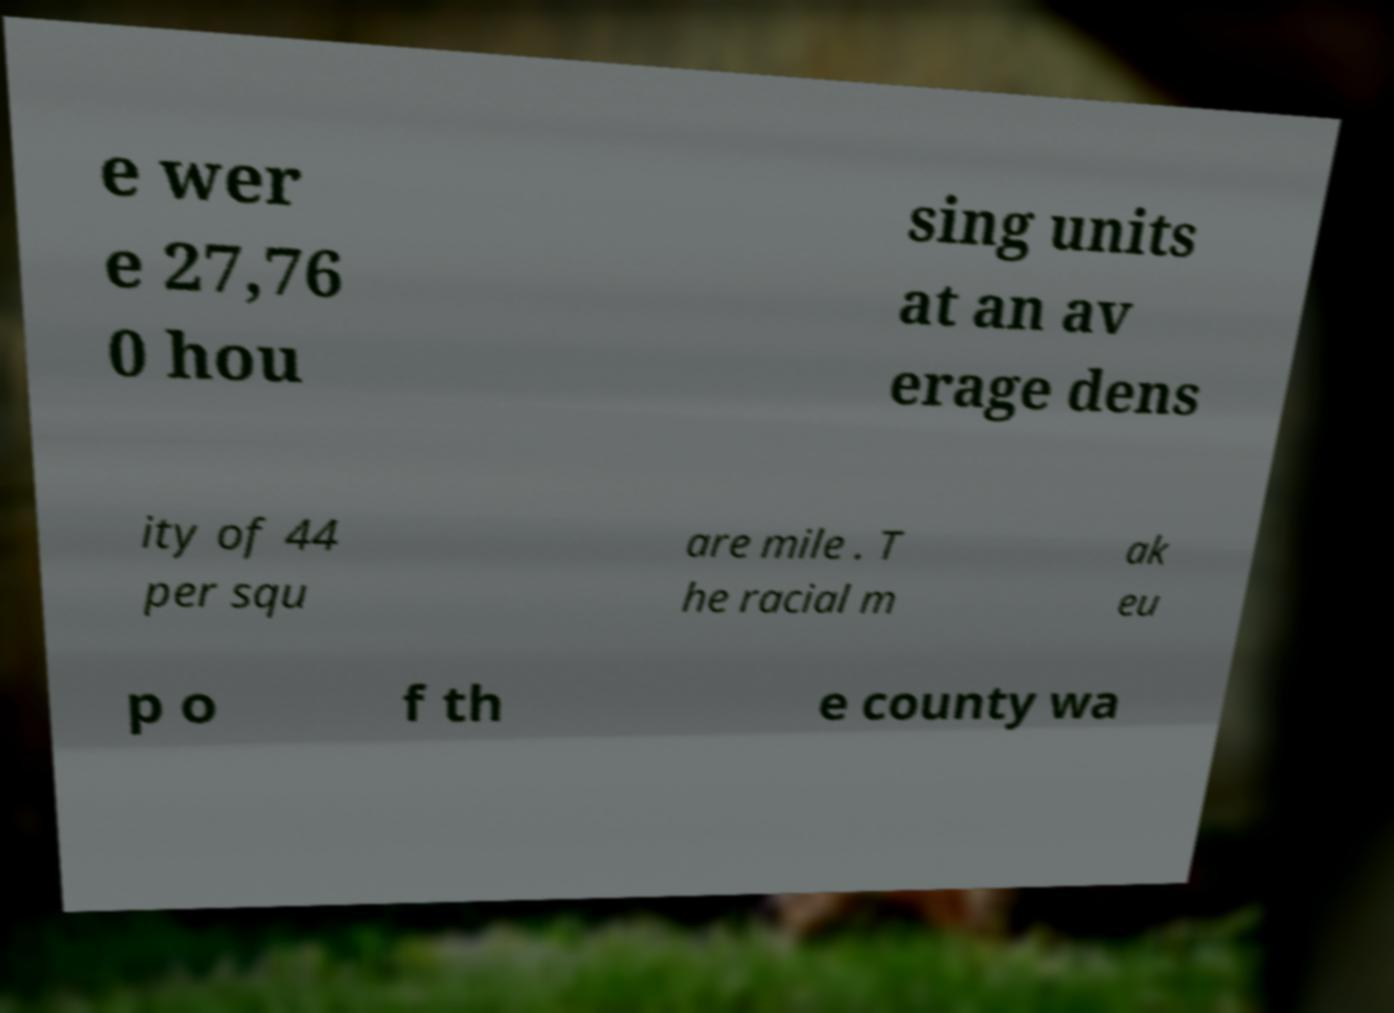I need the written content from this picture converted into text. Can you do that? e wer e 27,76 0 hou sing units at an av erage dens ity of 44 per squ are mile . T he racial m ak eu p o f th e county wa 